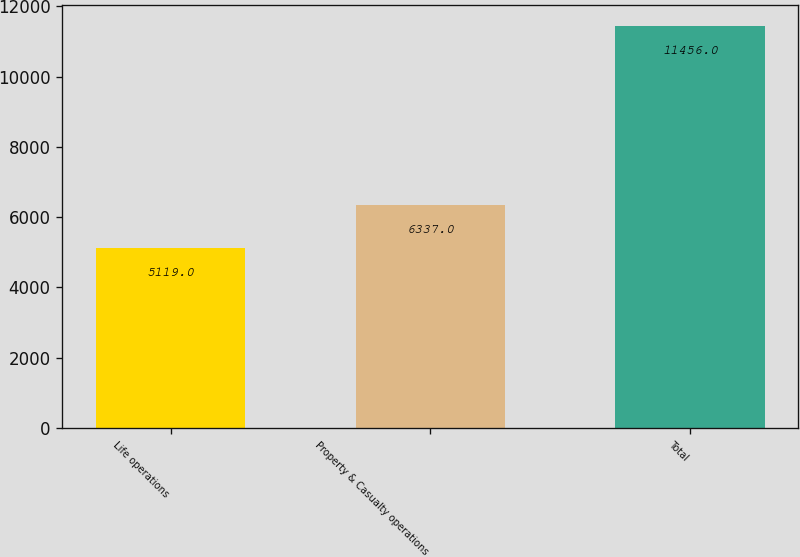Convert chart. <chart><loc_0><loc_0><loc_500><loc_500><bar_chart><fcel>Life operations<fcel>Property & Casualty operations<fcel>Total<nl><fcel>5119<fcel>6337<fcel>11456<nl></chart> 